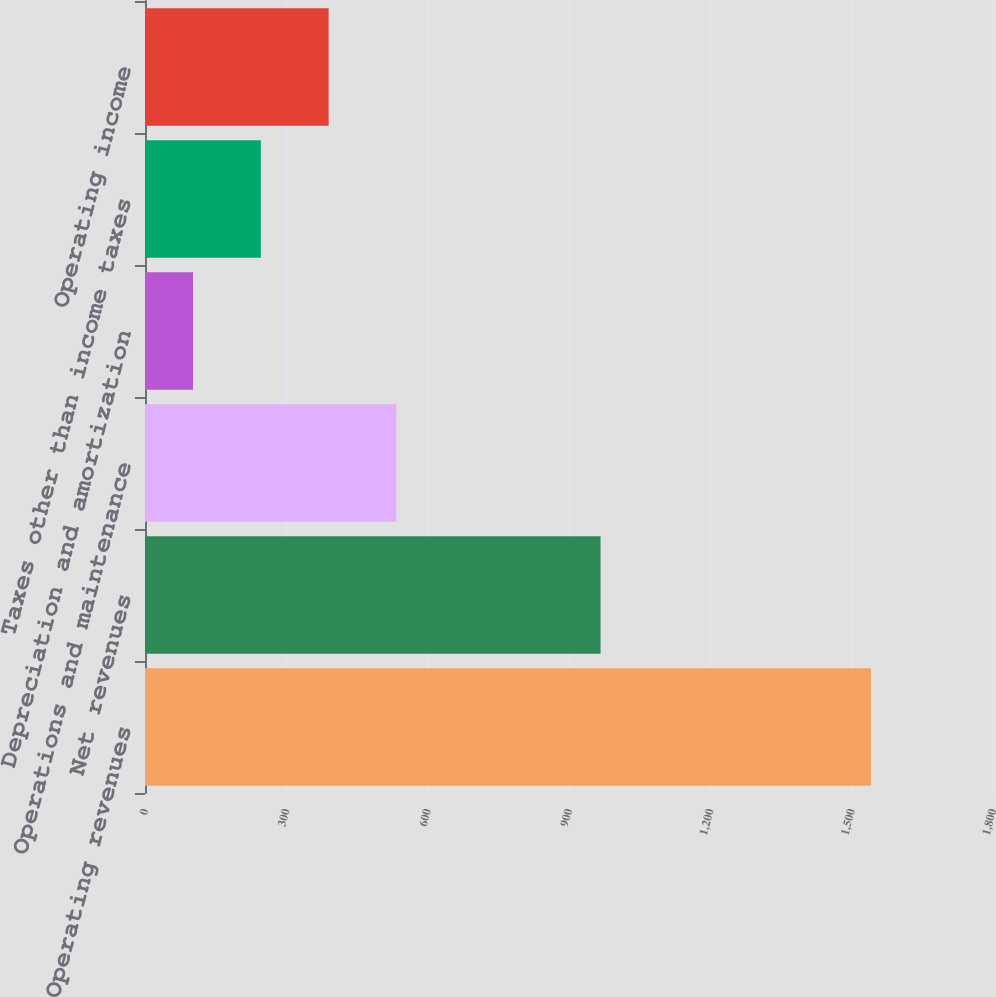Convert chart. <chart><loc_0><loc_0><loc_500><loc_500><bar_chart><fcel>Operating revenues<fcel>Net revenues<fcel>Operations and maintenance<fcel>Depreciation and amortization<fcel>Taxes other than income taxes<fcel>Operating income<nl><fcel>1541<fcel>967<fcel>533.7<fcel>102<fcel>245.9<fcel>389.8<nl></chart> 